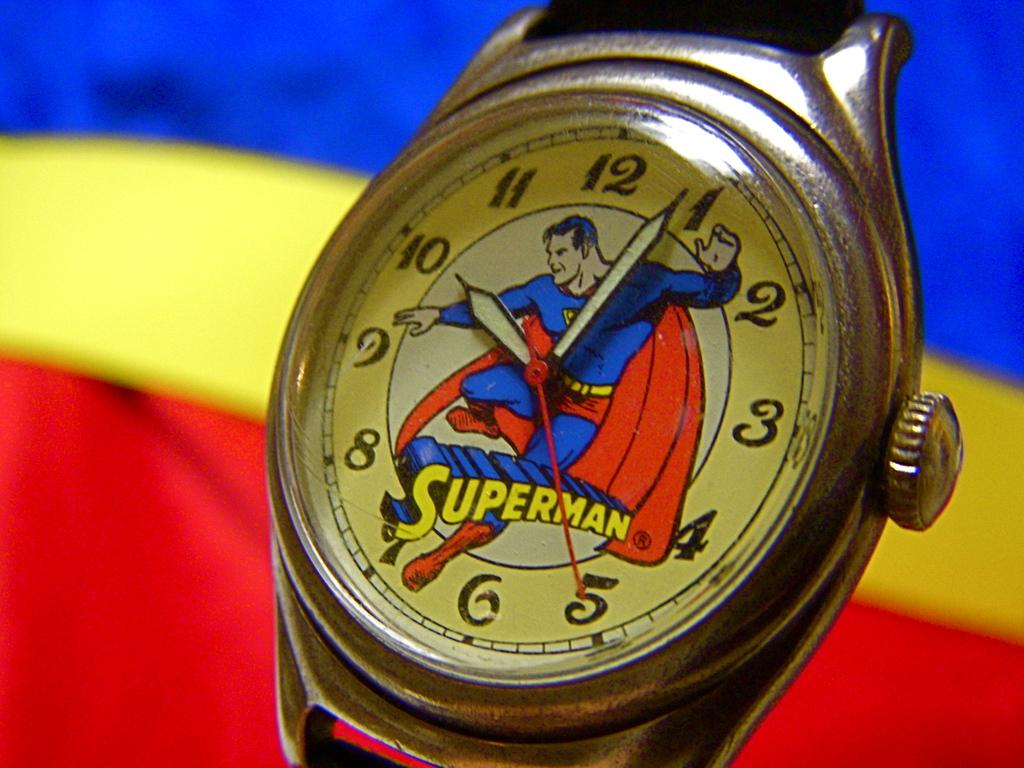At what number is the red hand pointing?
Offer a very short reply. 5. This a superman watch?
Give a very brief answer. Yes. 